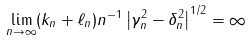<formula> <loc_0><loc_0><loc_500><loc_500>\lim _ { n \to \infty } ( k _ { n } + \ell _ { n } ) n ^ { - 1 } \left | \gamma _ { n } ^ { 2 } - \delta _ { n } ^ { 2 } \right | ^ { 1 / 2 } = \infty</formula> 